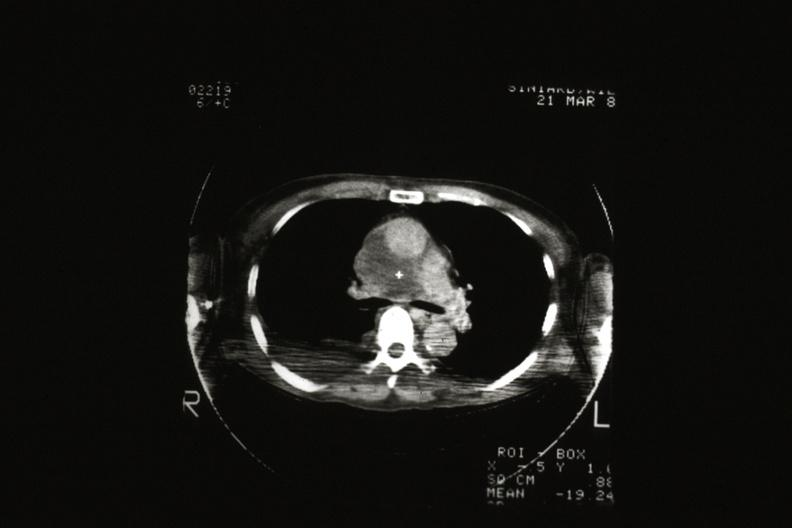what scan showing tumor invading superior vena ca?
Answer the question using a single word or phrase. Cat 